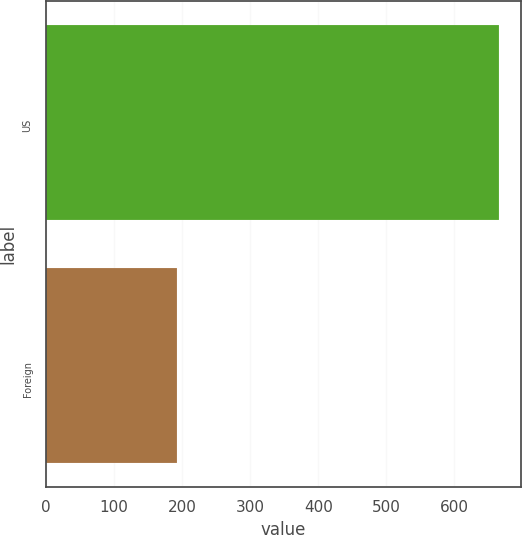Convert chart to OTSL. <chart><loc_0><loc_0><loc_500><loc_500><bar_chart><fcel>US<fcel>Foreign<nl><fcel>665<fcel>193<nl></chart> 